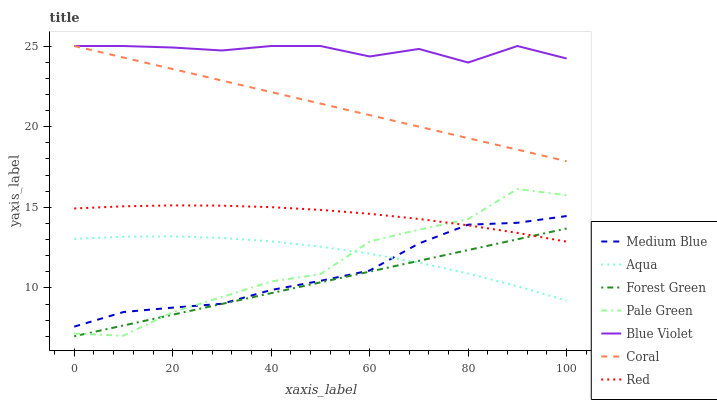Does Forest Green have the minimum area under the curve?
Answer yes or no. Yes. Does Blue Violet have the maximum area under the curve?
Answer yes or no. Yes. Does Coral have the minimum area under the curve?
Answer yes or no. No. Does Coral have the maximum area under the curve?
Answer yes or no. No. Is Coral the smoothest?
Answer yes or no. Yes. Is Pale Green the roughest?
Answer yes or no. Yes. Is Aqua the smoothest?
Answer yes or no. No. Is Aqua the roughest?
Answer yes or no. No. Does Forest Green have the lowest value?
Answer yes or no. Yes. Does Coral have the lowest value?
Answer yes or no. No. Does Blue Violet have the highest value?
Answer yes or no. Yes. Does Aqua have the highest value?
Answer yes or no. No. Is Forest Green less than Coral?
Answer yes or no. Yes. Is Blue Violet greater than Aqua?
Answer yes or no. Yes. Does Red intersect Medium Blue?
Answer yes or no. Yes. Is Red less than Medium Blue?
Answer yes or no. No. Is Red greater than Medium Blue?
Answer yes or no. No. Does Forest Green intersect Coral?
Answer yes or no. No. 